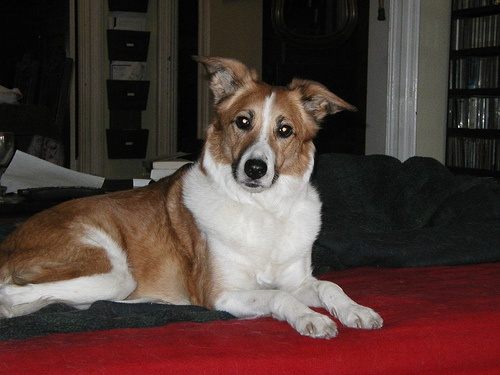Describe the objects in this image and their specific colors. I can see dog in black, lightgray, darkgray, maroon, and gray tones, bed in black, maroon, and gray tones, book in black and gray tones, book in black tones, and book in black, gray, and darkgray tones in this image. 